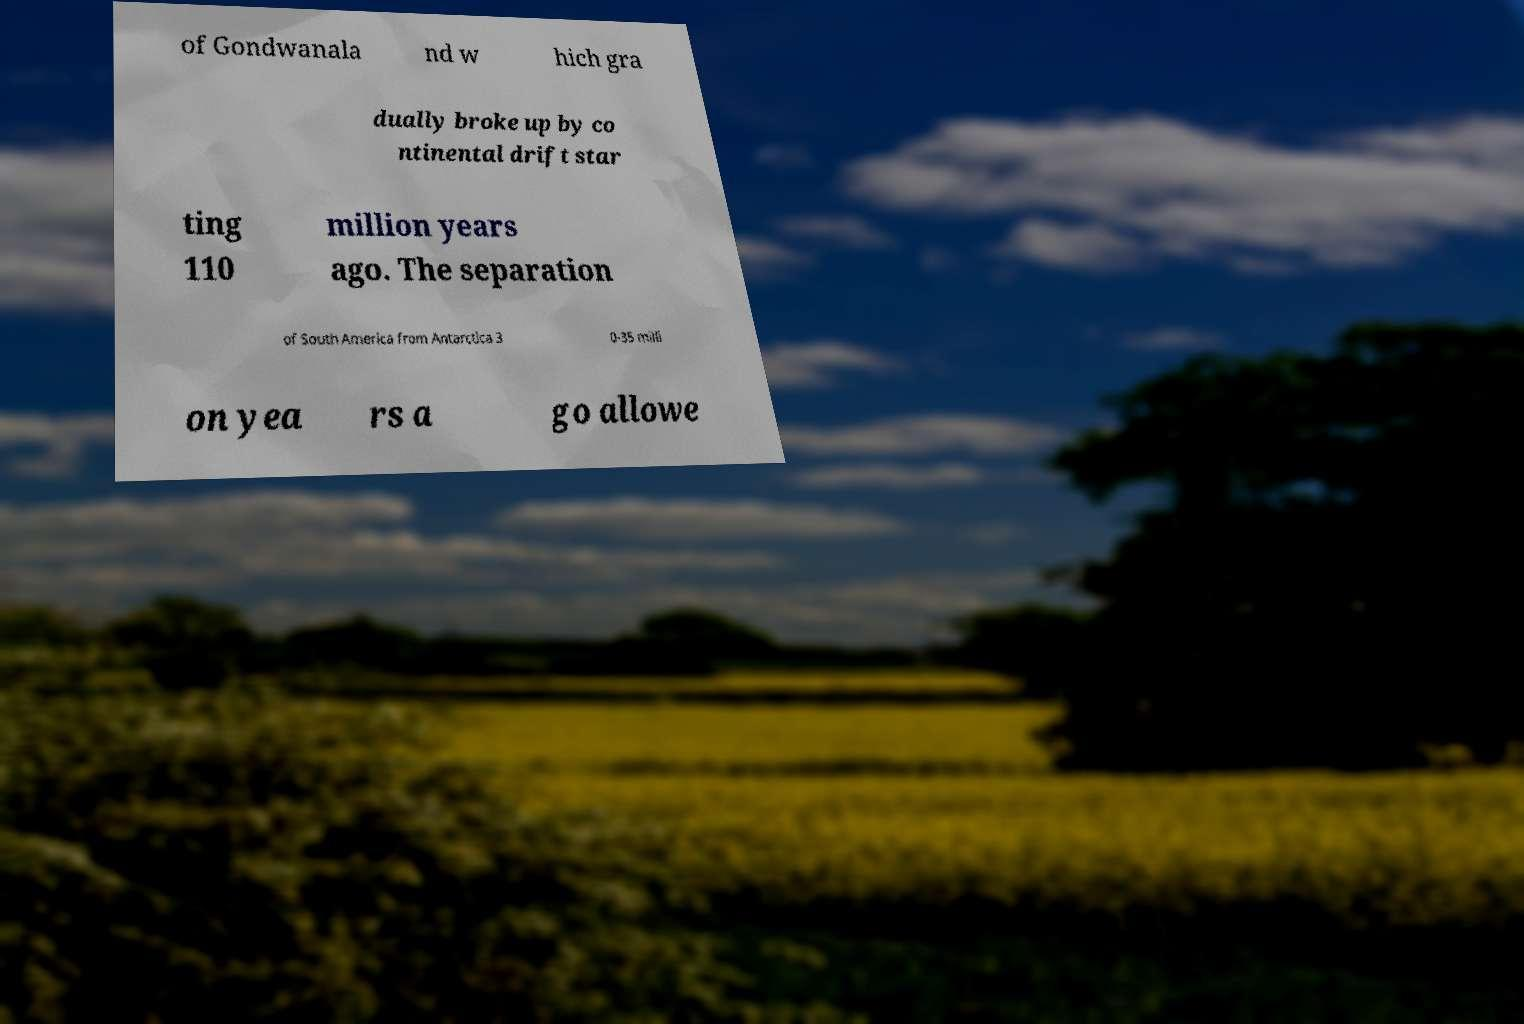Can you read and provide the text displayed in the image?This photo seems to have some interesting text. Can you extract and type it out for me? of Gondwanala nd w hich gra dually broke up by co ntinental drift star ting 110 million years ago. The separation of South America from Antarctica 3 0-35 milli on yea rs a go allowe 